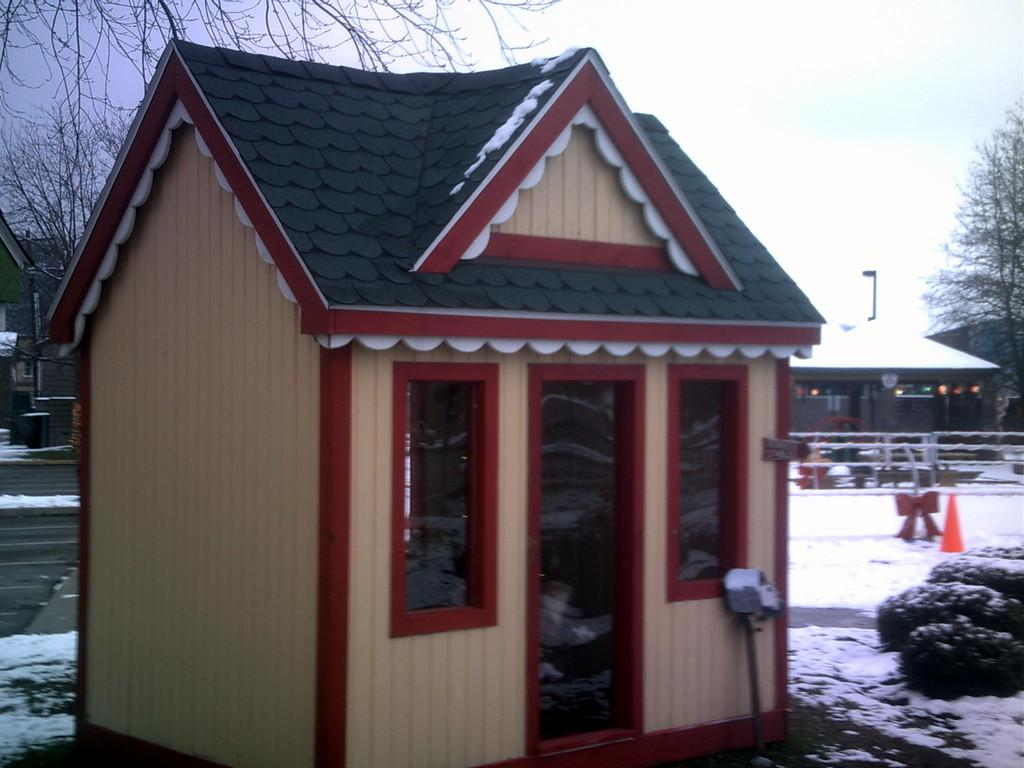What is the main subject in the middle of the image? There is a small house in the middle of the image. What can be seen in the background of the image? There are other houses in the background of the image. What type of vegetation is present in the image? There are trees in the image. What is the condition of the ground in the image? There is snow on the ground in the image. What is visible in the sky in the image? The sky is visible in the image. How many records can be seen on the ground in the image? There are no records present in the image; it features a small house, other houses, trees, snow on the ground, and a visible sky. 